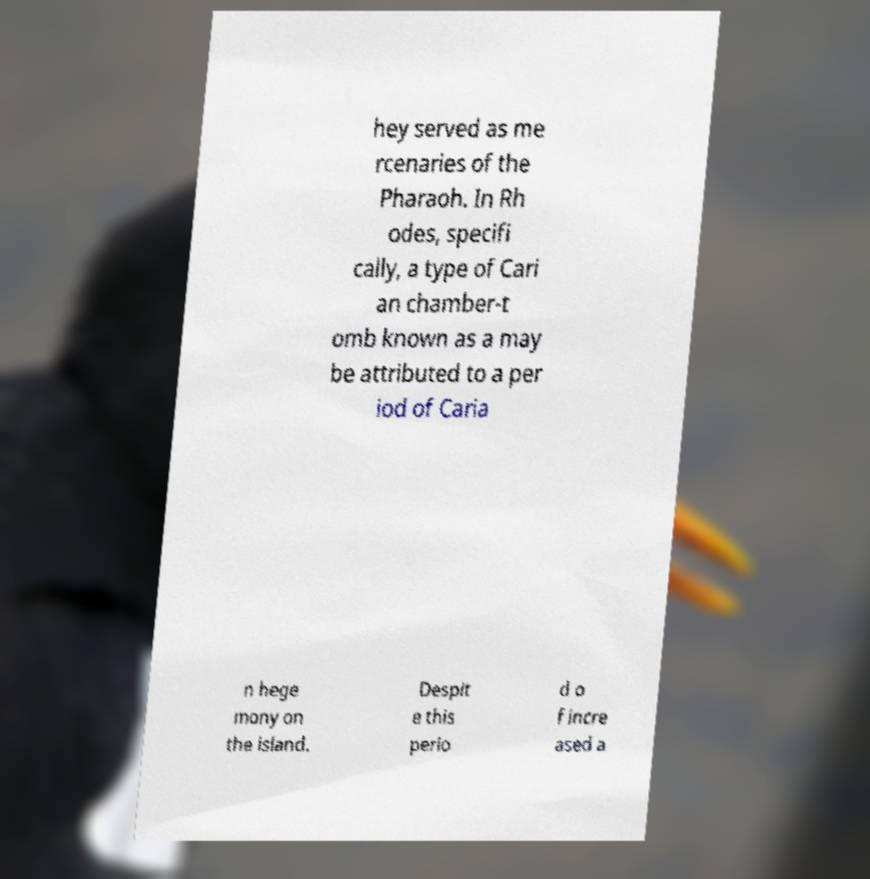For documentation purposes, I need the text within this image transcribed. Could you provide that? hey served as me rcenaries of the Pharaoh. In Rh odes, specifi cally, a type of Cari an chamber-t omb known as a may be attributed to a per iod of Caria n hege mony on the island. Despit e this perio d o f incre ased a 